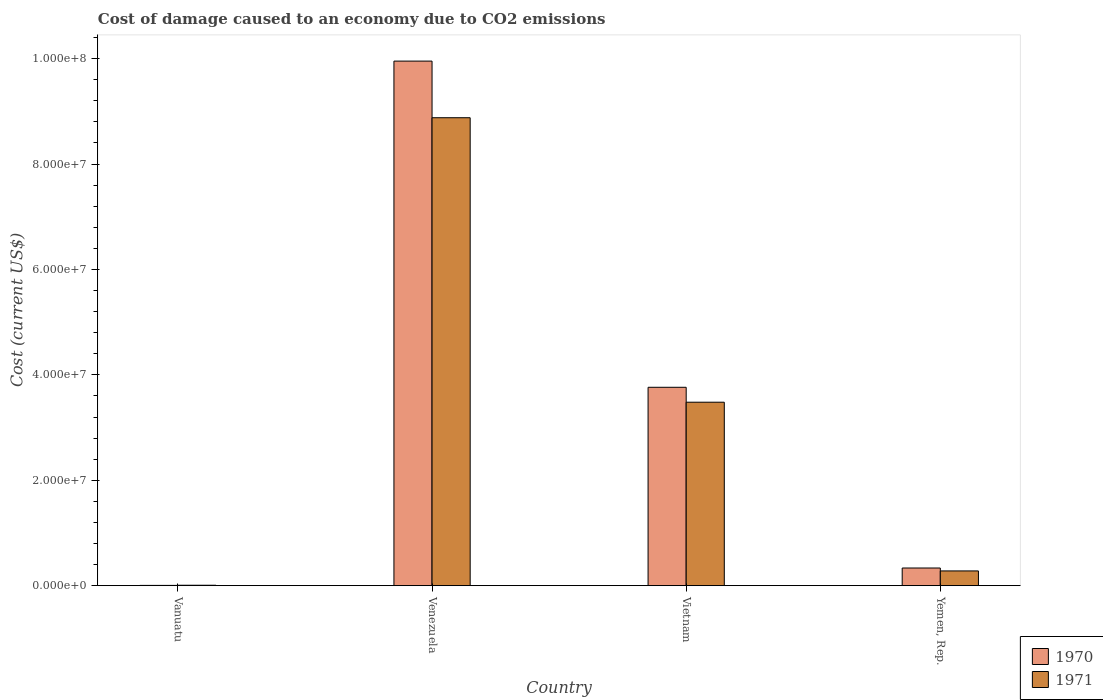How many bars are there on the 2nd tick from the left?
Offer a terse response. 2. How many bars are there on the 2nd tick from the right?
Keep it short and to the point. 2. What is the label of the 1st group of bars from the left?
Your response must be concise. Vanuatu. What is the cost of damage caused due to CO2 emissisons in 1971 in Yemen, Rep.?
Give a very brief answer. 2.80e+06. Across all countries, what is the maximum cost of damage caused due to CO2 emissisons in 1971?
Make the answer very short. 8.88e+07. Across all countries, what is the minimum cost of damage caused due to CO2 emissisons in 1970?
Provide a succinct answer. 5.38e+04. In which country was the cost of damage caused due to CO2 emissisons in 1970 maximum?
Give a very brief answer. Venezuela. In which country was the cost of damage caused due to CO2 emissisons in 1970 minimum?
Keep it short and to the point. Vanuatu. What is the total cost of damage caused due to CO2 emissisons in 1971 in the graph?
Provide a short and direct response. 1.26e+08. What is the difference between the cost of damage caused due to CO2 emissisons in 1971 in Vietnam and that in Yemen, Rep.?
Your response must be concise. 3.20e+07. What is the difference between the cost of damage caused due to CO2 emissisons in 1971 in Vietnam and the cost of damage caused due to CO2 emissisons in 1970 in Venezuela?
Your answer should be compact. -6.47e+07. What is the average cost of damage caused due to CO2 emissisons in 1970 per country?
Give a very brief answer. 3.51e+07. What is the difference between the cost of damage caused due to CO2 emissisons of/in 1970 and cost of damage caused due to CO2 emissisons of/in 1971 in Vietnam?
Provide a short and direct response. 2.83e+06. In how many countries, is the cost of damage caused due to CO2 emissisons in 1970 greater than 8000000 US$?
Make the answer very short. 2. What is the ratio of the cost of damage caused due to CO2 emissisons in 1970 in Vanuatu to that in Yemen, Rep.?
Keep it short and to the point. 0.02. Is the cost of damage caused due to CO2 emissisons in 1971 in Vanuatu less than that in Venezuela?
Your response must be concise. Yes. Is the difference between the cost of damage caused due to CO2 emissisons in 1970 in Venezuela and Vietnam greater than the difference between the cost of damage caused due to CO2 emissisons in 1971 in Venezuela and Vietnam?
Your response must be concise. Yes. What is the difference between the highest and the second highest cost of damage caused due to CO2 emissisons in 1971?
Your response must be concise. 8.60e+07. What is the difference between the highest and the lowest cost of damage caused due to CO2 emissisons in 1970?
Keep it short and to the point. 9.95e+07. Are all the bars in the graph horizontal?
Offer a very short reply. No. What is the difference between two consecutive major ticks on the Y-axis?
Offer a terse response. 2.00e+07. Are the values on the major ticks of Y-axis written in scientific E-notation?
Your answer should be very brief. Yes. Does the graph contain any zero values?
Provide a short and direct response. No. Where does the legend appear in the graph?
Your answer should be very brief. Bottom right. How many legend labels are there?
Your answer should be very brief. 2. What is the title of the graph?
Offer a very short reply. Cost of damage caused to an economy due to CO2 emissions. Does "1968" appear as one of the legend labels in the graph?
Offer a terse response. No. What is the label or title of the X-axis?
Make the answer very short. Country. What is the label or title of the Y-axis?
Offer a terse response. Cost (current US$). What is the Cost (current US$) in 1970 in Vanuatu?
Offer a terse response. 5.38e+04. What is the Cost (current US$) of 1971 in Vanuatu?
Keep it short and to the point. 8.33e+04. What is the Cost (current US$) in 1970 in Venezuela?
Offer a terse response. 9.95e+07. What is the Cost (current US$) of 1971 in Venezuela?
Ensure brevity in your answer.  8.88e+07. What is the Cost (current US$) of 1970 in Vietnam?
Provide a short and direct response. 3.76e+07. What is the Cost (current US$) in 1971 in Vietnam?
Provide a succinct answer. 3.48e+07. What is the Cost (current US$) in 1970 in Yemen, Rep.?
Ensure brevity in your answer.  3.35e+06. What is the Cost (current US$) of 1971 in Yemen, Rep.?
Give a very brief answer. 2.80e+06. Across all countries, what is the maximum Cost (current US$) in 1970?
Provide a succinct answer. 9.95e+07. Across all countries, what is the maximum Cost (current US$) in 1971?
Offer a very short reply. 8.88e+07. Across all countries, what is the minimum Cost (current US$) in 1970?
Your response must be concise. 5.38e+04. Across all countries, what is the minimum Cost (current US$) in 1971?
Offer a very short reply. 8.33e+04. What is the total Cost (current US$) in 1970 in the graph?
Your answer should be very brief. 1.41e+08. What is the total Cost (current US$) of 1971 in the graph?
Give a very brief answer. 1.26e+08. What is the difference between the Cost (current US$) in 1970 in Vanuatu and that in Venezuela?
Offer a terse response. -9.95e+07. What is the difference between the Cost (current US$) in 1971 in Vanuatu and that in Venezuela?
Provide a short and direct response. -8.87e+07. What is the difference between the Cost (current US$) in 1970 in Vanuatu and that in Vietnam?
Your answer should be very brief. -3.76e+07. What is the difference between the Cost (current US$) of 1971 in Vanuatu and that in Vietnam?
Provide a short and direct response. -3.47e+07. What is the difference between the Cost (current US$) in 1970 in Vanuatu and that in Yemen, Rep.?
Offer a terse response. -3.30e+06. What is the difference between the Cost (current US$) of 1971 in Vanuatu and that in Yemen, Rep.?
Your response must be concise. -2.72e+06. What is the difference between the Cost (current US$) in 1970 in Venezuela and that in Vietnam?
Provide a succinct answer. 6.19e+07. What is the difference between the Cost (current US$) of 1971 in Venezuela and that in Vietnam?
Ensure brevity in your answer.  5.40e+07. What is the difference between the Cost (current US$) in 1970 in Venezuela and that in Yemen, Rep.?
Your answer should be compact. 9.62e+07. What is the difference between the Cost (current US$) of 1971 in Venezuela and that in Yemen, Rep.?
Your answer should be very brief. 8.60e+07. What is the difference between the Cost (current US$) of 1970 in Vietnam and that in Yemen, Rep.?
Your answer should be compact. 3.43e+07. What is the difference between the Cost (current US$) in 1971 in Vietnam and that in Yemen, Rep.?
Give a very brief answer. 3.20e+07. What is the difference between the Cost (current US$) in 1970 in Vanuatu and the Cost (current US$) in 1971 in Venezuela?
Keep it short and to the point. -8.87e+07. What is the difference between the Cost (current US$) of 1970 in Vanuatu and the Cost (current US$) of 1971 in Vietnam?
Your answer should be very brief. -3.48e+07. What is the difference between the Cost (current US$) of 1970 in Vanuatu and the Cost (current US$) of 1971 in Yemen, Rep.?
Provide a succinct answer. -2.75e+06. What is the difference between the Cost (current US$) in 1970 in Venezuela and the Cost (current US$) in 1971 in Vietnam?
Offer a terse response. 6.47e+07. What is the difference between the Cost (current US$) in 1970 in Venezuela and the Cost (current US$) in 1971 in Yemen, Rep.?
Your response must be concise. 9.67e+07. What is the difference between the Cost (current US$) in 1970 in Vietnam and the Cost (current US$) in 1971 in Yemen, Rep.?
Give a very brief answer. 3.48e+07. What is the average Cost (current US$) in 1970 per country?
Keep it short and to the point. 3.51e+07. What is the average Cost (current US$) in 1971 per country?
Your answer should be very brief. 3.16e+07. What is the difference between the Cost (current US$) in 1970 and Cost (current US$) in 1971 in Vanuatu?
Your answer should be compact. -2.94e+04. What is the difference between the Cost (current US$) in 1970 and Cost (current US$) in 1971 in Venezuela?
Keep it short and to the point. 1.07e+07. What is the difference between the Cost (current US$) of 1970 and Cost (current US$) of 1971 in Vietnam?
Offer a very short reply. 2.83e+06. What is the difference between the Cost (current US$) in 1970 and Cost (current US$) in 1971 in Yemen, Rep.?
Offer a very short reply. 5.53e+05. What is the ratio of the Cost (current US$) of 1970 in Vanuatu to that in Venezuela?
Provide a short and direct response. 0. What is the ratio of the Cost (current US$) of 1971 in Vanuatu to that in Venezuela?
Provide a short and direct response. 0. What is the ratio of the Cost (current US$) of 1970 in Vanuatu to that in Vietnam?
Offer a very short reply. 0. What is the ratio of the Cost (current US$) in 1971 in Vanuatu to that in Vietnam?
Your answer should be compact. 0. What is the ratio of the Cost (current US$) in 1970 in Vanuatu to that in Yemen, Rep.?
Your answer should be compact. 0.02. What is the ratio of the Cost (current US$) in 1971 in Vanuatu to that in Yemen, Rep.?
Give a very brief answer. 0.03. What is the ratio of the Cost (current US$) in 1970 in Venezuela to that in Vietnam?
Your answer should be compact. 2.64. What is the ratio of the Cost (current US$) in 1971 in Venezuela to that in Vietnam?
Provide a succinct answer. 2.55. What is the ratio of the Cost (current US$) of 1970 in Venezuela to that in Yemen, Rep.?
Your answer should be very brief. 29.68. What is the ratio of the Cost (current US$) of 1971 in Venezuela to that in Yemen, Rep.?
Your answer should be compact. 31.71. What is the ratio of the Cost (current US$) of 1970 in Vietnam to that in Yemen, Rep.?
Offer a terse response. 11.23. What is the ratio of the Cost (current US$) of 1971 in Vietnam to that in Yemen, Rep.?
Ensure brevity in your answer.  12.43. What is the difference between the highest and the second highest Cost (current US$) of 1970?
Make the answer very short. 6.19e+07. What is the difference between the highest and the second highest Cost (current US$) in 1971?
Offer a very short reply. 5.40e+07. What is the difference between the highest and the lowest Cost (current US$) in 1970?
Offer a very short reply. 9.95e+07. What is the difference between the highest and the lowest Cost (current US$) of 1971?
Give a very brief answer. 8.87e+07. 